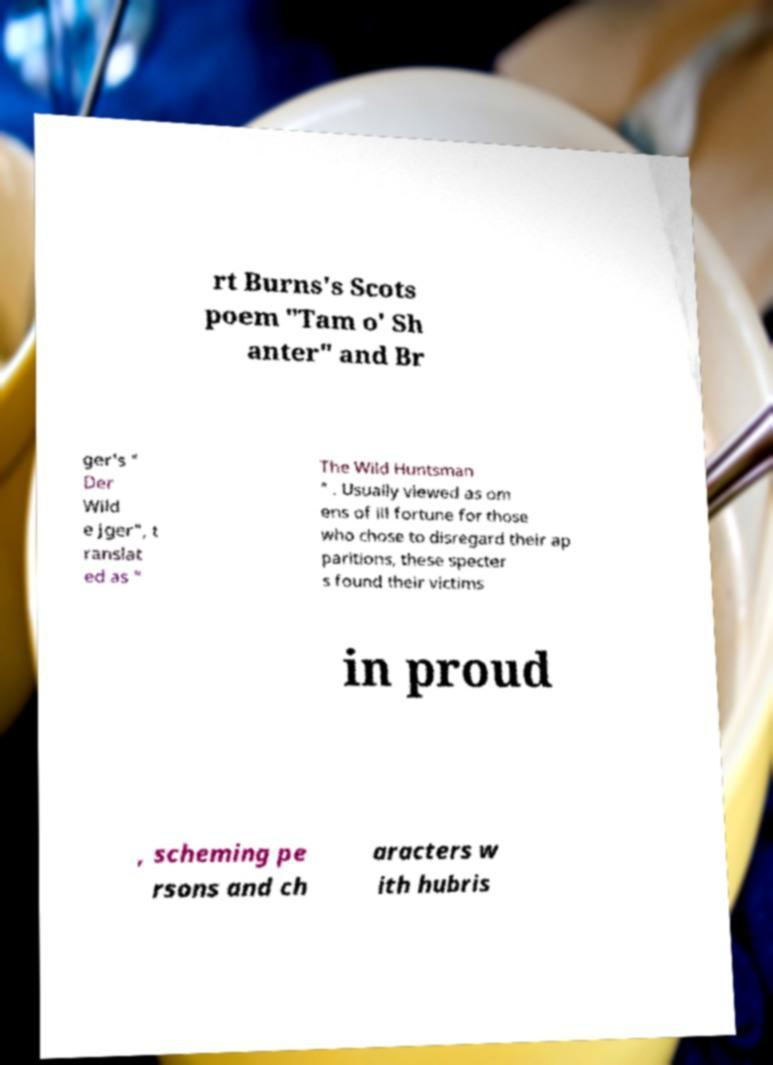I need the written content from this picture converted into text. Can you do that? rt Burns's Scots poem "Tam o' Sh anter" and Br ger's " Der Wild e Jger", t ranslat ed as " The Wild Huntsman " . Usually viewed as om ens of ill fortune for those who chose to disregard their ap paritions, these specter s found their victims in proud , scheming pe rsons and ch aracters w ith hubris 